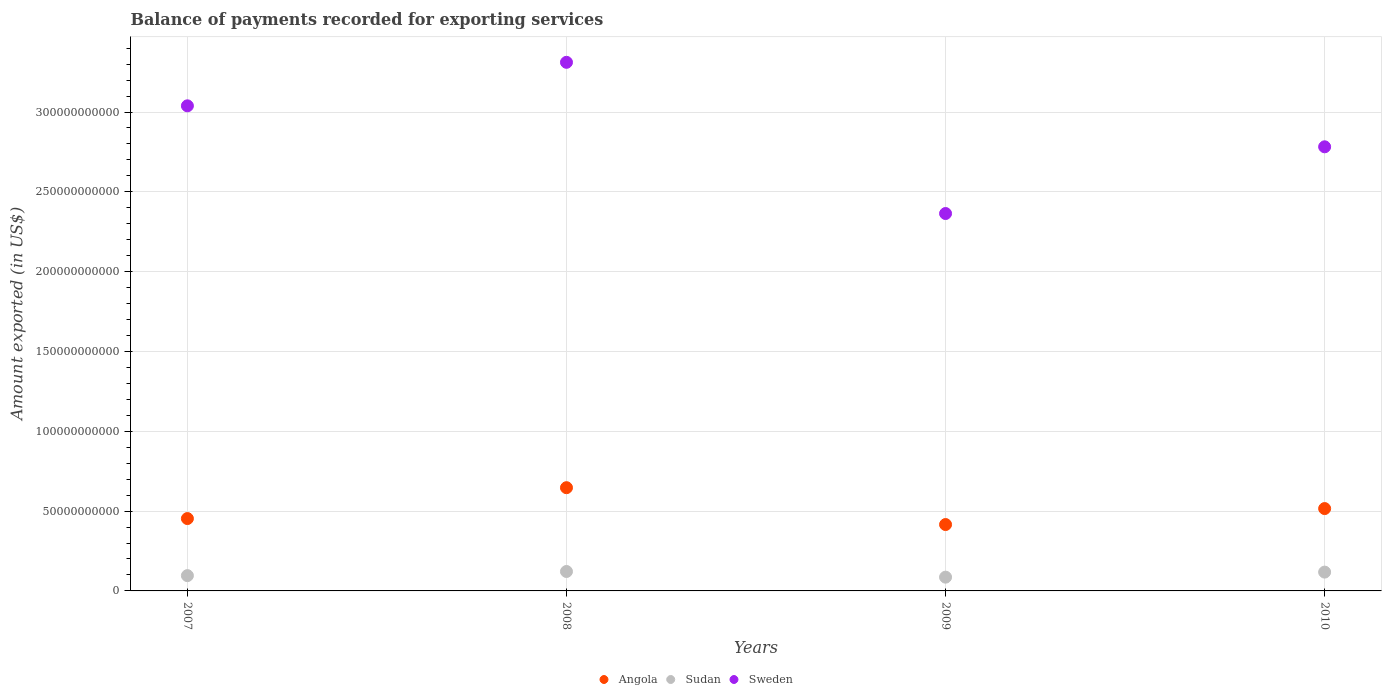How many different coloured dotlines are there?
Offer a terse response. 3. What is the amount exported in Angola in 2009?
Give a very brief answer. 4.16e+1. Across all years, what is the maximum amount exported in Sweden?
Give a very brief answer. 3.31e+11. Across all years, what is the minimum amount exported in Sweden?
Make the answer very short. 2.36e+11. In which year was the amount exported in Sudan maximum?
Offer a terse response. 2008. In which year was the amount exported in Angola minimum?
Make the answer very short. 2009. What is the total amount exported in Sweden in the graph?
Ensure brevity in your answer.  1.15e+12. What is the difference between the amount exported in Sudan in 2008 and that in 2009?
Your response must be concise. 3.55e+09. What is the difference between the amount exported in Angola in 2008 and the amount exported in Sweden in 2009?
Ensure brevity in your answer.  -1.72e+11. What is the average amount exported in Sudan per year?
Ensure brevity in your answer.  1.05e+1. In the year 2007, what is the difference between the amount exported in Angola and amount exported in Sudan?
Your answer should be compact. 3.57e+1. What is the ratio of the amount exported in Sudan in 2009 to that in 2010?
Make the answer very short. 0.73. Is the amount exported in Angola in 2007 less than that in 2008?
Provide a short and direct response. Yes. What is the difference between the highest and the second highest amount exported in Angola?
Offer a very short reply. 1.31e+1. What is the difference between the highest and the lowest amount exported in Sweden?
Provide a succinct answer. 9.47e+1. In how many years, is the amount exported in Sudan greater than the average amount exported in Sudan taken over all years?
Your answer should be compact. 2. Is the sum of the amount exported in Sudan in 2007 and 2010 greater than the maximum amount exported in Sweden across all years?
Give a very brief answer. No. Is it the case that in every year, the sum of the amount exported in Sweden and amount exported in Sudan  is greater than the amount exported in Angola?
Provide a succinct answer. Yes. Is the amount exported in Sweden strictly greater than the amount exported in Sudan over the years?
Make the answer very short. Yes. Is the amount exported in Sweden strictly less than the amount exported in Angola over the years?
Your answer should be very brief. No. How many years are there in the graph?
Keep it short and to the point. 4. What is the difference between two consecutive major ticks on the Y-axis?
Ensure brevity in your answer.  5.00e+1. Are the values on the major ticks of Y-axis written in scientific E-notation?
Provide a succinct answer. No. Does the graph contain any zero values?
Provide a short and direct response. No. Where does the legend appear in the graph?
Your answer should be very brief. Bottom center. What is the title of the graph?
Ensure brevity in your answer.  Balance of payments recorded for exporting services. Does "Gabon" appear as one of the legend labels in the graph?
Provide a short and direct response. No. What is the label or title of the X-axis?
Give a very brief answer. Years. What is the label or title of the Y-axis?
Offer a terse response. Amount exported (in US$). What is the Amount exported (in US$) in Angola in 2007?
Ensure brevity in your answer.  4.53e+1. What is the Amount exported (in US$) in Sudan in 2007?
Provide a short and direct response. 9.58e+09. What is the Amount exported (in US$) of Sweden in 2007?
Provide a short and direct response. 3.04e+11. What is the Amount exported (in US$) of Angola in 2008?
Give a very brief answer. 6.47e+1. What is the Amount exported (in US$) in Sudan in 2008?
Give a very brief answer. 1.22e+1. What is the Amount exported (in US$) in Sweden in 2008?
Your answer should be compact. 3.31e+11. What is the Amount exported (in US$) in Angola in 2009?
Give a very brief answer. 4.16e+1. What is the Amount exported (in US$) in Sudan in 2009?
Ensure brevity in your answer.  8.62e+09. What is the Amount exported (in US$) in Sweden in 2009?
Your response must be concise. 2.36e+11. What is the Amount exported (in US$) of Angola in 2010?
Ensure brevity in your answer.  5.16e+1. What is the Amount exported (in US$) in Sudan in 2010?
Give a very brief answer. 1.18e+1. What is the Amount exported (in US$) in Sweden in 2010?
Give a very brief answer. 2.78e+11. Across all years, what is the maximum Amount exported (in US$) of Angola?
Provide a short and direct response. 6.47e+1. Across all years, what is the maximum Amount exported (in US$) in Sudan?
Ensure brevity in your answer.  1.22e+1. Across all years, what is the maximum Amount exported (in US$) of Sweden?
Provide a succinct answer. 3.31e+11. Across all years, what is the minimum Amount exported (in US$) of Angola?
Ensure brevity in your answer.  4.16e+1. Across all years, what is the minimum Amount exported (in US$) in Sudan?
Your answer should be very brief. 8.62e+09. Across all years, what is the minimum Amount exported (in US$) in Sweden?
Your answer should be very brief. 2.36e+11. What is the total Amount exported (in US$) in Angola in the graph?
Your answer should be very brief. 2.03e+11. What is the total Amount exported (in US$) of Sudan in the graph?
Make the answer very short. 4.22e+1. What is the total Amount exported (in US$) in Sweden in the graph?
Your response must be concise. 1.15e+12. What is the difference between the Amount exported (in US$) in Angola in 2007 and that in 2008?
Your response must be concise. -1.93e+1. What is the difference between the Amount exported (in US$) of Sudan in 2007 and that in 2008?
Keep it short and to the point. -2.59e+09. What is the difference between the Amount exported (in US$) in Sweden in 2007 and that in 2008?
Your answer should be very brief. -2.73e+1. What is the difference between the Amount exported (in US$) in Angola in 2007 and that in 2009?
Your answer should be very brief. 3.75e+09. What is the difference between the Amount exported (in US$) in Sudan in 2007 and that in 2009?
Your answer should be compact. 9.65e+08. What is the difference between the Amount exported (in US$) of Sweden in 2007 and that in 2009?
Offer a very short reply. 6.75e+1. What is the difference between the Amount exported (in US$) in Angola in 2007 and that in 2010?
Keep it short and to the point. -6.26e+09. What is the difference between the Amount exported (in US$) in Sudan in 2007 and that in 2010?
Offer a very short reply. -2.20e+09. What is the difference between the Amount exported (in US$) of Sweden in 2007 and that in 2010?
Provide a short and direct response. 2.57e+1. What is the difference between the Amount exported (in US$) of Angola in 2008 and that in 2009?
Offer a terse response. 2.31e+1. What is the difference between the Amount exported (in US$) in Sudan in 2008 and that in 2009?
Provide a succinct answer. 3.55e+09. What is the difference between the Amount exported (in US$) in Sweden in 2008 and that in 2009?
Provide a short and direct response. 9.47e+1. What is the difference between the Amount exported (in US$) in Angola in 2008 and that in 2010?
Give a very brief answer. 1.31e+1. What is the difference between the Amount exported (in US$) of Sudan in 2008 and that in 2010?
Your answer should be compact. 3.84e+08. What is the difference between the Amount exported (in US$) in Sweden in 2008 and that in 2010?
Make the answer very short. 5.29e+1. What is the difference between the Amount exported (in US$) in Angola in 2009 and that in 2010?
Your answer should be compact. -1.00e+1. What is the difference between the Amount exported (in US$) of Sudan in 2009 and that in 2010?
Your response must be concise. -3.17e+09. What is the difference between the Amount exported (in US$) of Sweden in 2009 and that in 2010?
Your answer should be very brief. -4.18e+1. What is the difference between the Amount exported (in US$) of Angola in 2007 and the Amount exported (in US$) of Sudan in 2008?
Offer a terse response. 3.32e+1. What is the difference between the Amount exported (in US$) in Angola in 2007 and the Amount exported (in US$) in Sweden in 2008?
Give a very brief answer. -2.86e+11. What is the difference between the Amount exported (in US$) of Sudan in 2007 and the Amount exported (in US$) of Sweden in 2008?
Your response must be concise. -3.22e+11. What is the difference between the Amount exported (in US$) in Angola in 2007 and the Amount exported (in US$) in Sudan in 2009?
Keep it short and to the point. 3.67e+1. What is the difference between the Amount exported (in US$) in Angola in 2007 and the Amount exported (in US$) in Sweden in 2009?
Your response must be concise. -1.91e+11. What is the difference between the Amount exported (in US$) of Sudan in 2007 and the Amount exported (in US$) of Sweden in 2009?
Offer a very short reply. -2.27e+11. What is the difference between the Amount exported (in US$) of Angola in 2007 and the Amount exported (in US$) of Sudan in 2010?
Keep it short and to the point. 3.35e+1. What is the difference between the Amount exported (in US$) in Angola in 2007 and the Amount exported (in US$) in Sweden in 2010?
Ensure brevity in your answer.  -2.33e+11. What is the difference between the Amount exported (in US$) of Sudan in 2007 and the Amount exported (in US$) of Sweden in 2010?
Keep it short and to the point. -2.69e+11. What is the difference between the Amount exported (in US$) of Angola in 2008 and the Amount exported (in US$) of Sudan in 2009?
Provide a short and direct response. 5.60e+1. What is the difference between the Amount exported (in US$) of Angola in 2008 and the Amount exported (in US$) of Sweden in 2009?
Your answer should be very brief. -1.72e+11. What is the difference between the Amount exported (in US$) of Sudan in 2008 and the Amount exported (in US$) of Sweden in 2009?
Offer a terse response. -2.24e+11. What is the difference between the Amount exported (in US$) of Angola in 2008 and the Amount exported (in US$) of Sudan in 2010?
Offer a terse response. 5.29e+1. What is the difference between the Amount exported (in US$) of Angola in 2008 and the Amount exported (in US$) of Sweden in 2010?
Provide a succinct answer. -2.14e+11. What is the difference between the Amount exported (in US$) of Sudan in 2008 and the Amount exported (in US$) of Sweden in 2010?
Keep it short and to the point. -2.66e+11. What is the difference between the Amount exported (in US$) in Angola in 2009 and the Amount exported (in US$) in Sudan in 2010?
Offer a terse response. 2.98e+1. What is the difference between the Amount exported (in US$) in Angola in 2009 and the Amount exported (in US$) in Sweden in 2010?
Your answer should be compact. -2.37e+11. What is the difference between the Amount exported (in US$) in Sudan in 2009 and the Amount exported (in US$) in Sweden in 2010?
Make the answer very short. -2.70e+11. What is the average Amount exported (in US$) of Angola per year?
Your answer should be very brief. 5.08e+1. What is the average Amount exported (in US$) of Sudan per year?
Your response must be concise. 1.05e+1. What is the average Amount exported (in US$) of Sweden per year?
Offer a very short reply. 2.87e+11. In the year 2007, what is the difference between the Amount exported (in US$) in Angola and Amount exported (in US$) in Sudan?
Ensure brevity in your answer.  3.57e+1. In the year 2007, what is the difference between the Amount exported (in US$) in Angola and Amount exported (in US$) in Sweden?
Your answer should be compact. -2.59e+11. In the year 2007, what is the difference between the Amount exported (in US$) in Sudan and Amount exported (in US$) in Sweden?
Keep it short and to the point. -2.94e+11. In the year 2008, what is the difference between the Amount exported (in US$) in Angola and Amount exported (in US$) in Sudan?
Make the answer very short. 5.25e+1. In the year 2008, what is the difference between the Amount exported (in US$) of Angola and Amount exported (in US$) of Sweden?
Your answer should be compact. -2.66e+11. In the year 2008, what is the difference between the Amount exported (in US$) in Sudan and Amount exported (in US$) in Sweden?
Keep it short and to the point. -3.19e+11. In the year 2009, what is the difference between the Amount exported (in US$) in Angola and Amount exported (in US$) in Sudan?
Offer a very short reply. 3.30e+1. In the year 2009, what is the difference between the Amount exported (in US$) of Angola and Amount exported (in US$) of Sweden?
Your response must be concise. -1.95e+11. In the year 2009, what is the difference between the Amount exported (in US$) of Sudan and Amount exported (in US$) of Sweden?
Keep it short and to the point. -2.28e+11. In the year 2010, what is the difference between the Amount exported (in US$) of Angola and Amount exported (in US$) of Sudan?
Offer a terse response. 3.98e+1. In the year 2010, what is the difference between the Amount exported (in US$) of Angola and Amount exported (in US$) of Sweden?
Keep it short and to the point. -2.27e+11. In the year 2010, what is the difference between the Amount exported (in US$) in Sudan and Amount exported (in US$) in Sweden?
Ensure brevity in your answer.  -2.66e+11. What is the ratio of the Amount exported (in US$) of Angola in 2007 to that in 2008?
Offer a very short reply. 0.7. What is the ratio of the Amount exported (in US$) of Sudan in 2007 to that in 2008?
Keep it short and to the point. 0.79. What is the ratio of the Amount exported (in US$) of Sweden in 2007 to that in 2008?
Your answer should be very brief. 0.92. What is the ratio of the Amount exported (in US$) of Angola in 2007 to that in 2009?
Offer a very short reply. 1.09. What is the ratio of the Amount exported (in US$) of Sudan in 2007 to that in 2009?
Make the answer very short. 1.11. What is the ratio of the Amount exported (in US$) of Sweden in 2007 to that in 2009?
Provide a short and direct response. 1.29. What is the ratio of the Amount exported (in US$) in Angola in 2007 to that in 2010?
Keep it short and to the point. 0.88. What is the ratio of the Amount exported (in US$) in Sudan in 2007 to that in 2010?
Give a very brief answer. 0.81. What is the ratio of the Amount exported (in US$) in Sweden in 2007 to that in 2010?
Ensure brevity in your answer.  1.09. What is the ratio of the Amount exported (in US$) of Angola in 2008 to that in 2009?
Provide a short and direct response. 1.56. What is the ratio of the Amount exported (in US$) of Sudan in 2008 to that in 2009?
Your answer should be compact. 1.41. What is the ratio of the Amount exported (in US$) of Sweden in 2008 to that in 2009?
Provide a succinct answer. 1.4. What is the ratio of the Amount exported (in US$) of Angola in 2008 to that in 2010?
Provide a short and direct response. 1.25. What is the ratio of the Amount exported (in US$) of Sudan in 2008 to that in 2010?
Ensure brevity in your answer.  1.03. What is the ratio of the Amount exported (in US$) in Sweden in 2008 to that in 2010?
Offer a very short reply. 1.19. What is the ratio of the Amount exported (in US$) in Angola in 2009 to that in 2010?
Provide a short and direct response. 0.81. What is the ratio of the Amount exported (in US$) in Sudan in 2009 to that in 2010?
Keep it short and to the point. 0.73. What is the ratio of the Amount exported (in US$) in Sweden in 2009 to that in 2010?
Give a very brief answer. 0.85. What is the difference between the highest and the second highest Amount exported (in US$) in Angola?
Your response must be concise. 1.31e+1. What is the difference between the highest and the second highest Amount exported (in US$) in Sudan?
Offer a terse response. 3.84e+08. What is the difference between the highest and the second highest Amount exported (in US$) in Sweden?
Make the answer very short. 2.73e+1. What is the difference between the highest and the lowest Amount exported (in US$) in Angola?
Provide a short and direct response. 2.31e+1. What is the difference between the highest and the lowest Amount exported (in US$) of Sudan?
Provide a succinct answer. 3.55e+09. What is the difference between the highest and the lowest Amount exported (in US$) of Sweden?
Provide a short and direct response. 9.47e+1. 